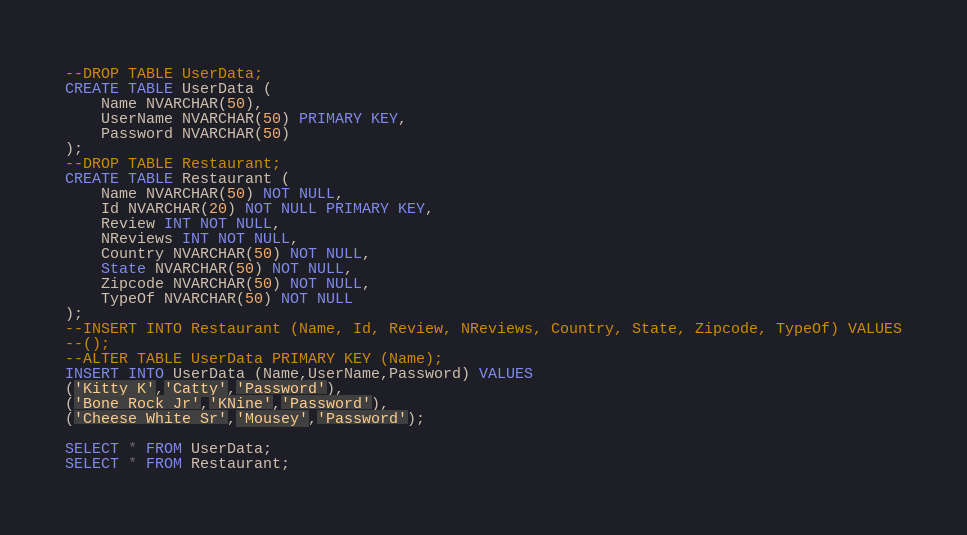Convert code to text. <code><loc_0><loc_0><loc_500><loc_500><_SQL_>--DROP TABLE UserData;
CREATE TABLE UserData (
    Name NVARCHAR(50),
    UserName NVARCHAR(50) PRIMARY KEY,
    Password NVARCHAR(50)
);
--DROP TABLE Restaurant;
CREATE TABLE Restaurant (
    Name NVARCHAR(50) NOT NULL,
    Id NVARCHAR(20) NOT NULL PRIMARY KEY,
    Review INT NOT NULL,
    NReviews INT NOT NULL,
    Country NVARCHAR(50) NOT NULL,
    State NVARCHAR(50) NOT NULL,
    Zipcode NVARCHAR(50) NOT NULL,
    TypeOf NVARCHAR(50) NOT NULL
);
--INSERT INTO Restaurant (Name, Id, Review, NReviews, Country, State, Zipcode, TypeOf) VALUES
--();
--ALTER TABLE UserData PRIMARY KEY (Name);
INSERT INTO UserData (Name,UserName,Password) VALUES
('Kitty K','Catty','Password'),
('Bone Rock Jr','KNine','Password'),
('Cheese White Sr','Mousey','Password');

SELECT * FROM UserData;
SELECT * FROM Restaurant;</code> 